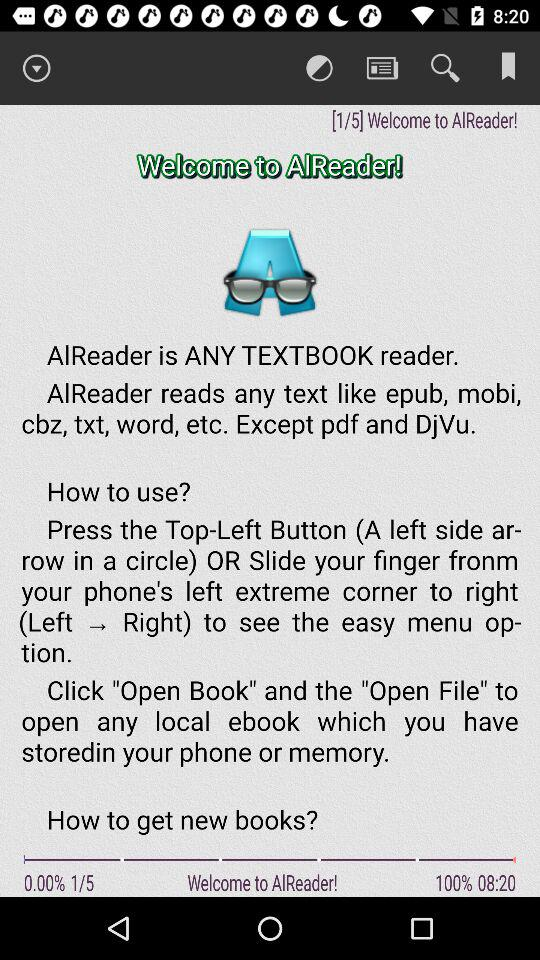What time is displayed on the screen? The time displayed on the screen is 08:20. 